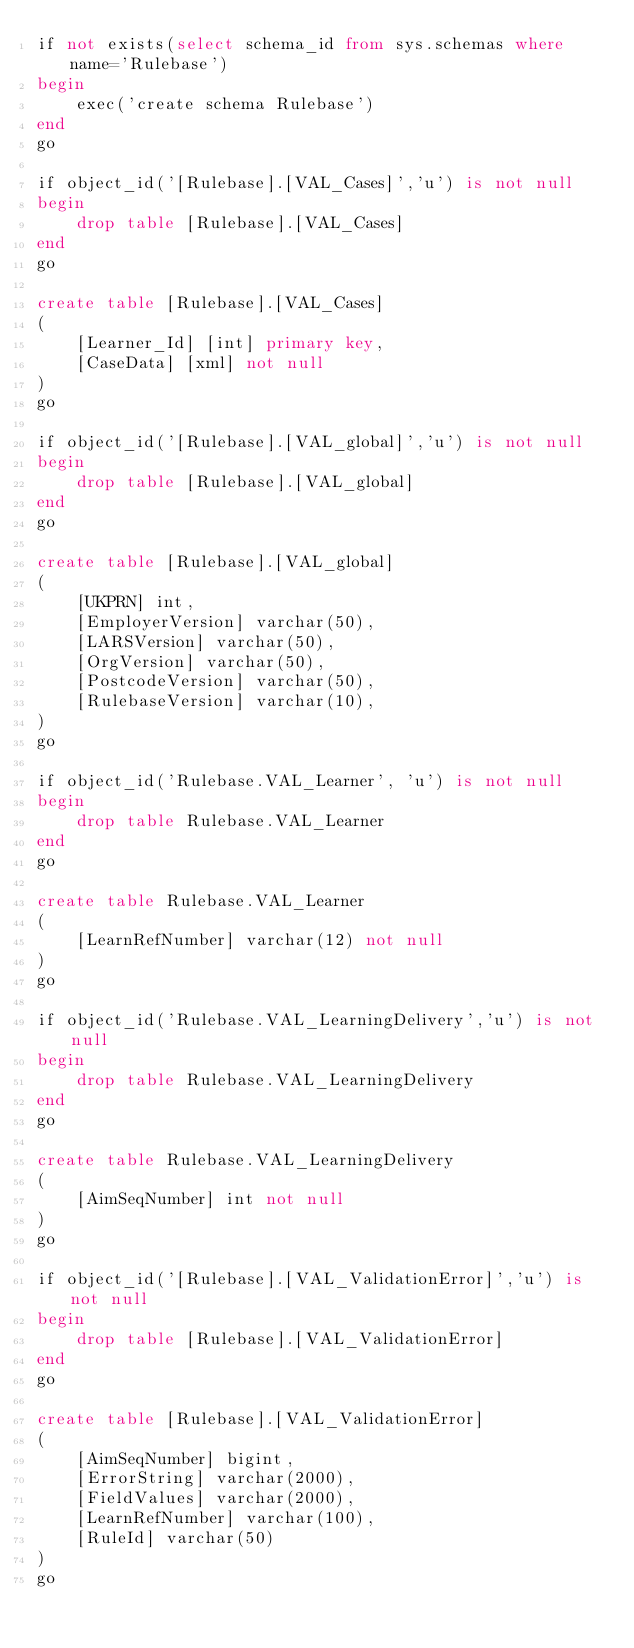<code> <loc_0><loc_0><loc_500><loc_500><_SQL_>if not exists(select schema_id from sys.schemas where name='Rulebase')
begin
	exec('create schema Rulebase')
end
go

if object_id('[Rulebase].[VAL_Cases]','u') is not null
begin
	drop table [Rulebase].[VAL_Cases]
end
go

create table [Rulebase].[VAL_Cases]
(
	[Learner_Id] [int] primary key,
	[CaseData] [xml] not null
)
go

if object_id('[Rulebase].[VAL_global]','u') is not null
begin
	drop table [Rulebase].[VAL_global]
end
go

create table [Rulebase].[VAL_global]
(
	[UKPRN] int,
	[EmployerVersion] varchar(50),
	[LARSVersion] varchar(50),
	[OrgVersion] varchar(50),
	[PostcodeVersion] varchar(50),
	[RulebaseVersion] varchar(10),
)
go

if object_id('Rulebase.VAL_Learner', 'u') is not null
begin
	drop table Rulebase.VAL_Learner
end
go

create table Rulebase.VAL_Learner
(
	[LearnRefNumber] varchar(12) not null
)
go

if object_id('Rulebase.VAL_LearningDelivery','u') is not null
begin
	drop table Rulebase.VAL_LearningDelivery
end
go

create table Rulebase.VAL_LearningDelivery
(
	[AimSeqNumber] int not null
)
go

if object_id('[Rulebase].[VAL_ValidationError]','u') is not null
begin
	drop table [Rulebase].[VAL_ValidationError]
end
go

create table [Rulebase].[VAL_ValidationError]
(
	[AimSeqNumber] bigint,
	[ErrorString] varchar(2000),
	[FieldValues] varchar(2000),
	[LearnRefNumber] varchar(100),
	[RuleId] varchar(50)
)
go
</code> 